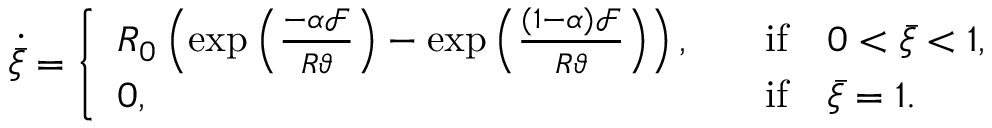<formula> <loc_0><loc_0><loc_500><loc_500>\dot { \bar { \xi } } = \left \{ \begin{array} { l l } { R _ { 0 } \left ( \exp \left ( \frac { - \alpha \mathcal { F } } { R \vartheta } \right ) - \exp \left ( \frac { ( 1 - \alpha ) \mathcal { F } } { R \vartheta } \right ) \right ) , } & { \quad i f \quad 0 < \bar { \xi } < 1 , } \\ { 0 , } & { \quad i f \quad \bar { \xi } = 1 . } \end{array}</formula> 